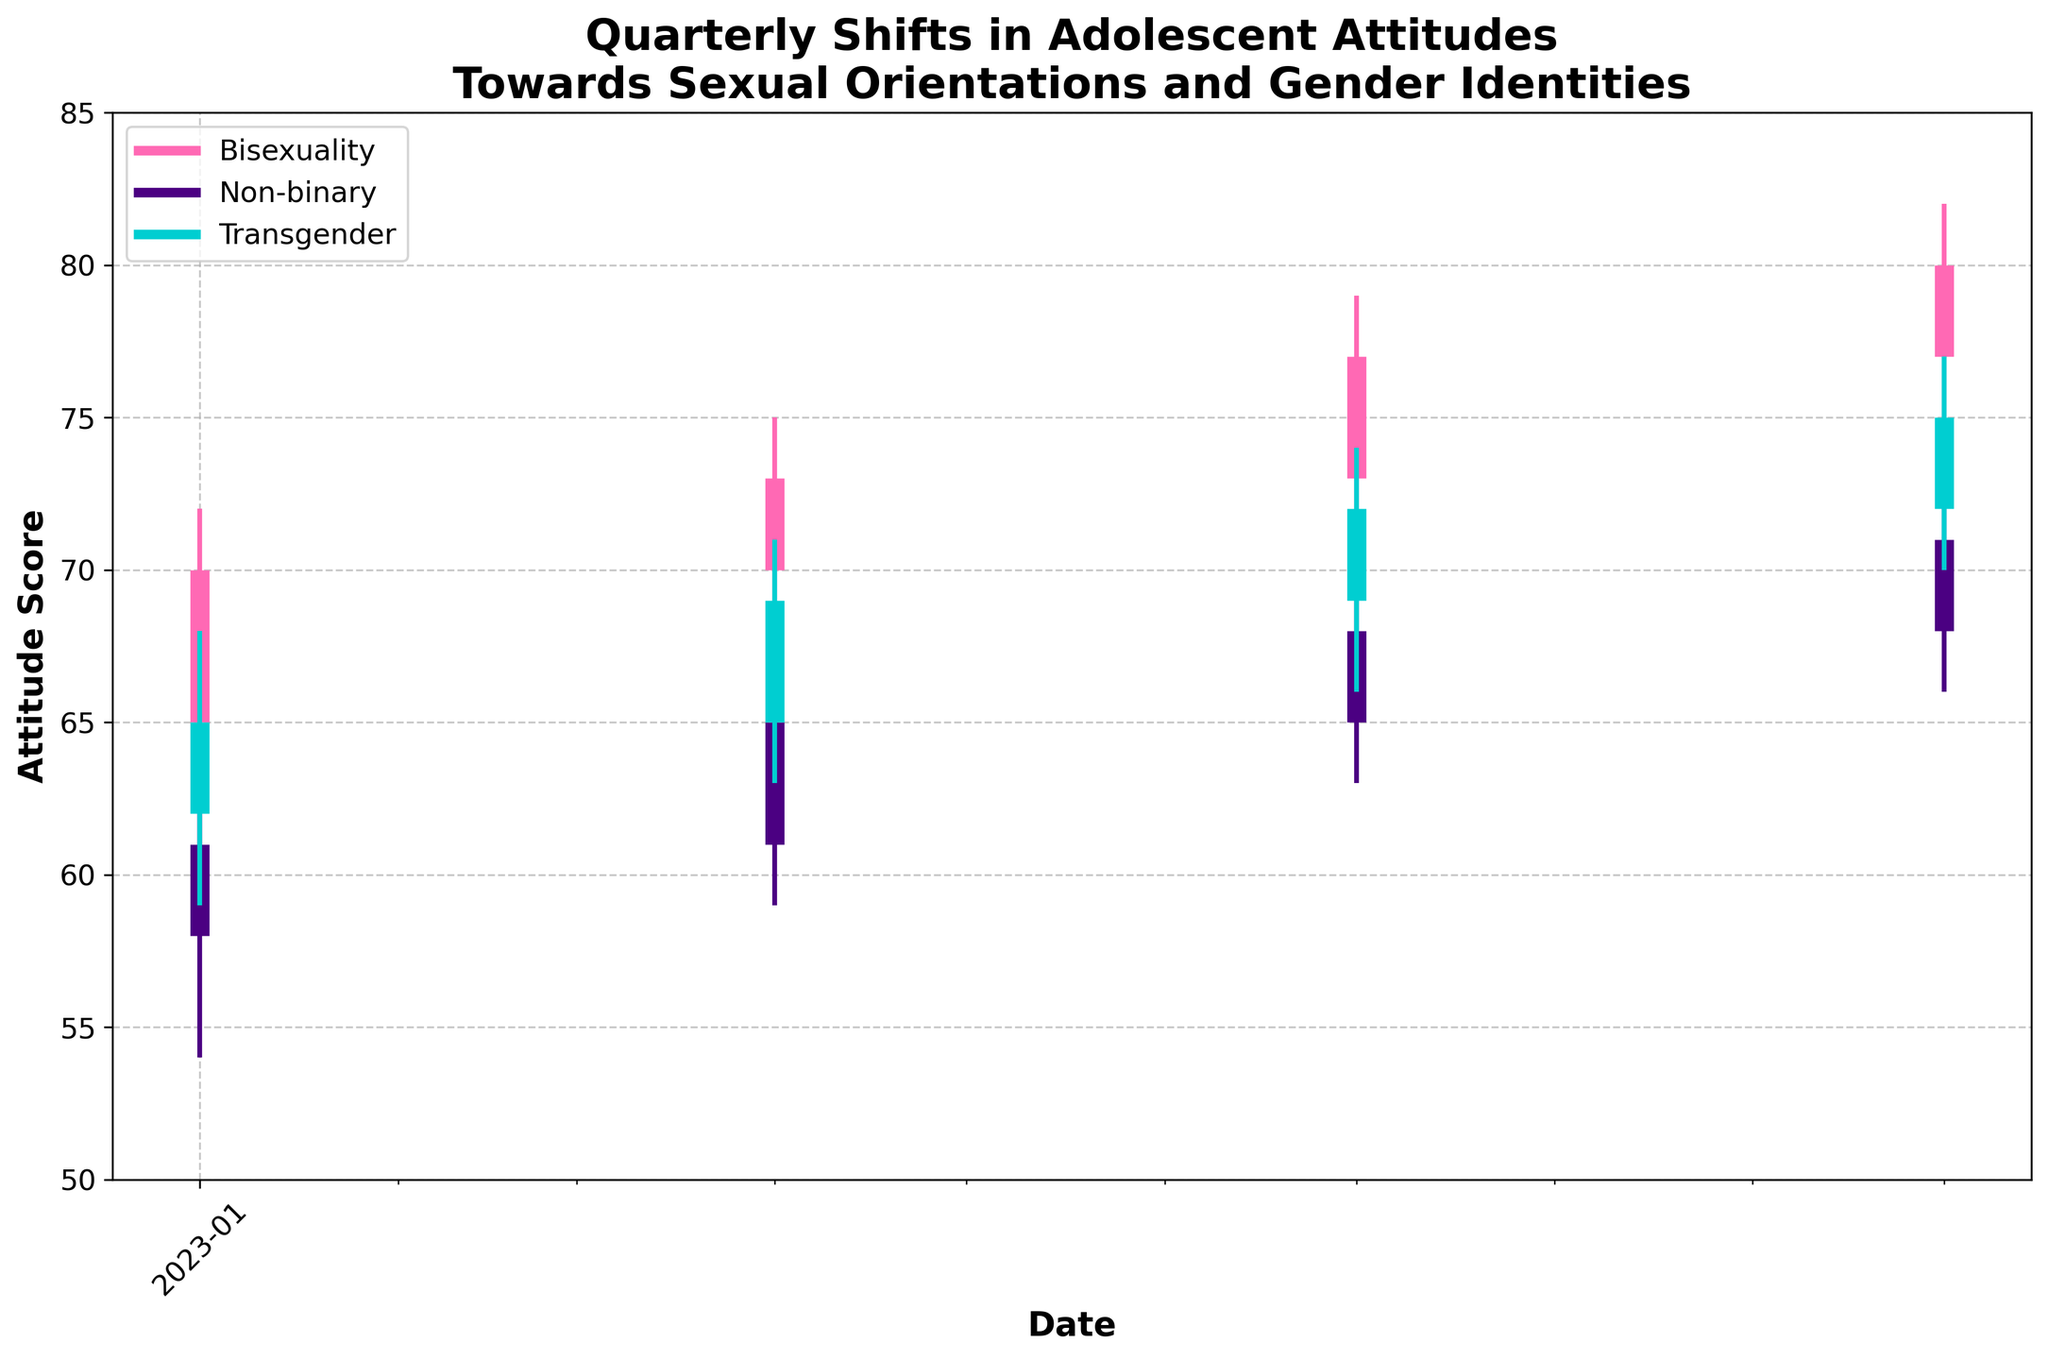What is the title of the plot? The title is found at the top of the plot and gives an overall description of the data being visualized.
Answer: Quarterly Shifts in Adolescent Attitudes Towards Sexual Orientations and Gender Identities What is the lowest attitude score for Bisexuality in 2023-Q1? The lowest attitude score corresponds to the low value for Bisexuality in 2023-Q1 as indicated on the y-axis.
Answer: 61 What is the range (difference between the high and low) of the attitude score for Transgender in 2023-Q4? The range is calculated by subtracting the low value from the high value for Transgender in 2023-Q4.
Answer: 7 (77 - 70 = 7) Between which quarters did the attitude score for Non-binary show the greatest increase in closing value? To find this, subtract the closing values between consecutive quarters and find the largest positive difference.
Answer: 2023-Q2 to 2023-Q3 (68 - 65 = 3) Which orientation/identity has the highest closing attitude score in 2023-Q4? Examine the closing values of each orientation/identity for 2023-Q4 and compare them.
Answer: Bisexuality What is the average of the opening scores for Non-binary across all quarters? Sum the opening scores for Non-binary across all quarters and divide by the number of quarters.
Answer: 63 ( (58 + 61 + 65 + 68) / 4 = 63 ) Did the closing attitude score for Transgender ever decrease from one quarter to the next? Check the closing values of Transgender across consecutive quarters to see if any decrease.
Answer: No Which quarter showed the highest fluctuation (difference between high and low) in attitude scores for Bisexuality? Calculate the difference between high and low for Bisexuality in each quarter and compare them.
Answer: 2023-Q4 (82 - 75 = 7) How many distinct colors are used to represent the different orientations/identities? Count the number of unique colors used in the plot. Each color represents a different orientation/identity.
Answer: 3 What is the closing attitude score for Non-binary in 2023-Q3? The closing score for Non-binary in 2023-Q3 is shown as 'Close' in the data for that quarter and orientation.
Answer: 68 